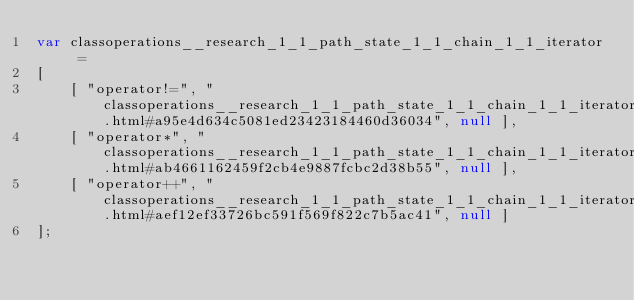Convert code to text. <code><loc_0><loc_0><loc_500><loc_500><_JavaScript_>var classoperations__research_1_1_path_state_1_1_chain_1_1_iterator =
[
    [ "operator!=", "classoperations__research_1_1_path_state_1_1_chain_1_1_iterator.html#a95e4d634c5081ed23423184460d36034", null ],
    [ "operator*", "classoperations__research_1_1_path_state_1_1_chain_1_1_iterator.html#ab4661162459f2cb4e9887fcbc2d38b55", null ],
    [ "operator++", "classoperations__research_1_1_path_state_1_1_chain_1_1_iterator.html#aef12ef33726bc591f569f822c7b5ac41", null ]
];</code> 